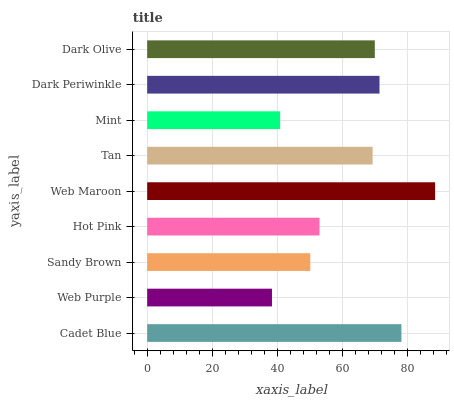Is Web Purple the minimum?
Answer yes or no. Yes. Is Web Maroon the maximum?
Answer yes or no. Yes. Is Sandy Brown the minimum?
Answer yes or no. No. Is Sandy Brown the maximum?
Answer yes or no. No. Is Sandy Brown greater than Web Purple?
Answer yes or no. Yes. Is Web Purple less than Sandy Brown?
Answer yes or no. Yes. Is Web Purple greater than Sandy Brown?
Answer yes or no. No. Is Sandy Brown less than Web Purple?
Answer yes or no. No. Is Tan the high median?
Answer yes or no. Yes. Is Tan the low median?
Answer yes or no. Yes. Is Dark Olive the high median?
Answer yes or no. No. Is Dark Periwinkle the low median?
Answer yes or no. No. 